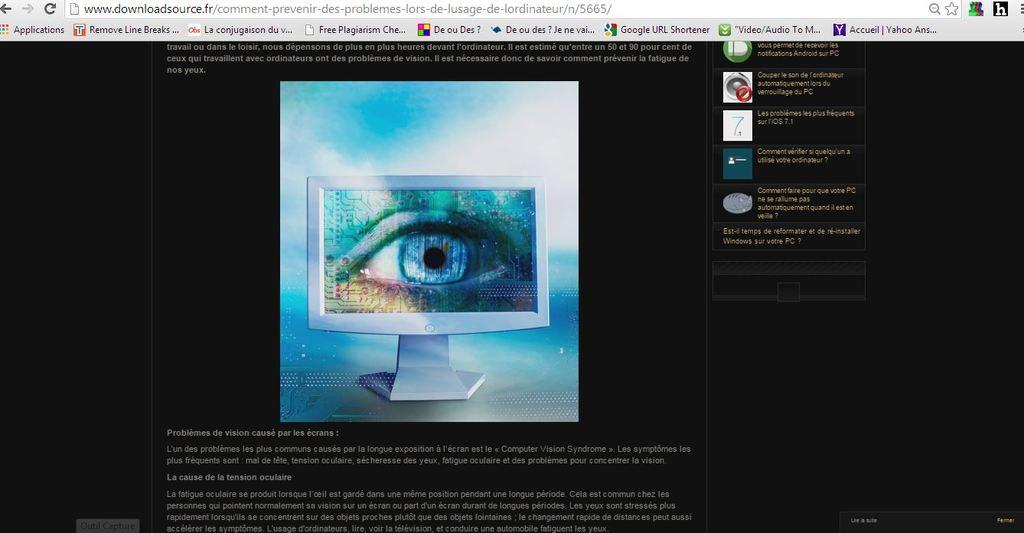<image>
Provide a brief description of the given image. a computer screen with a window open  to www.downloadsource.fr/ 